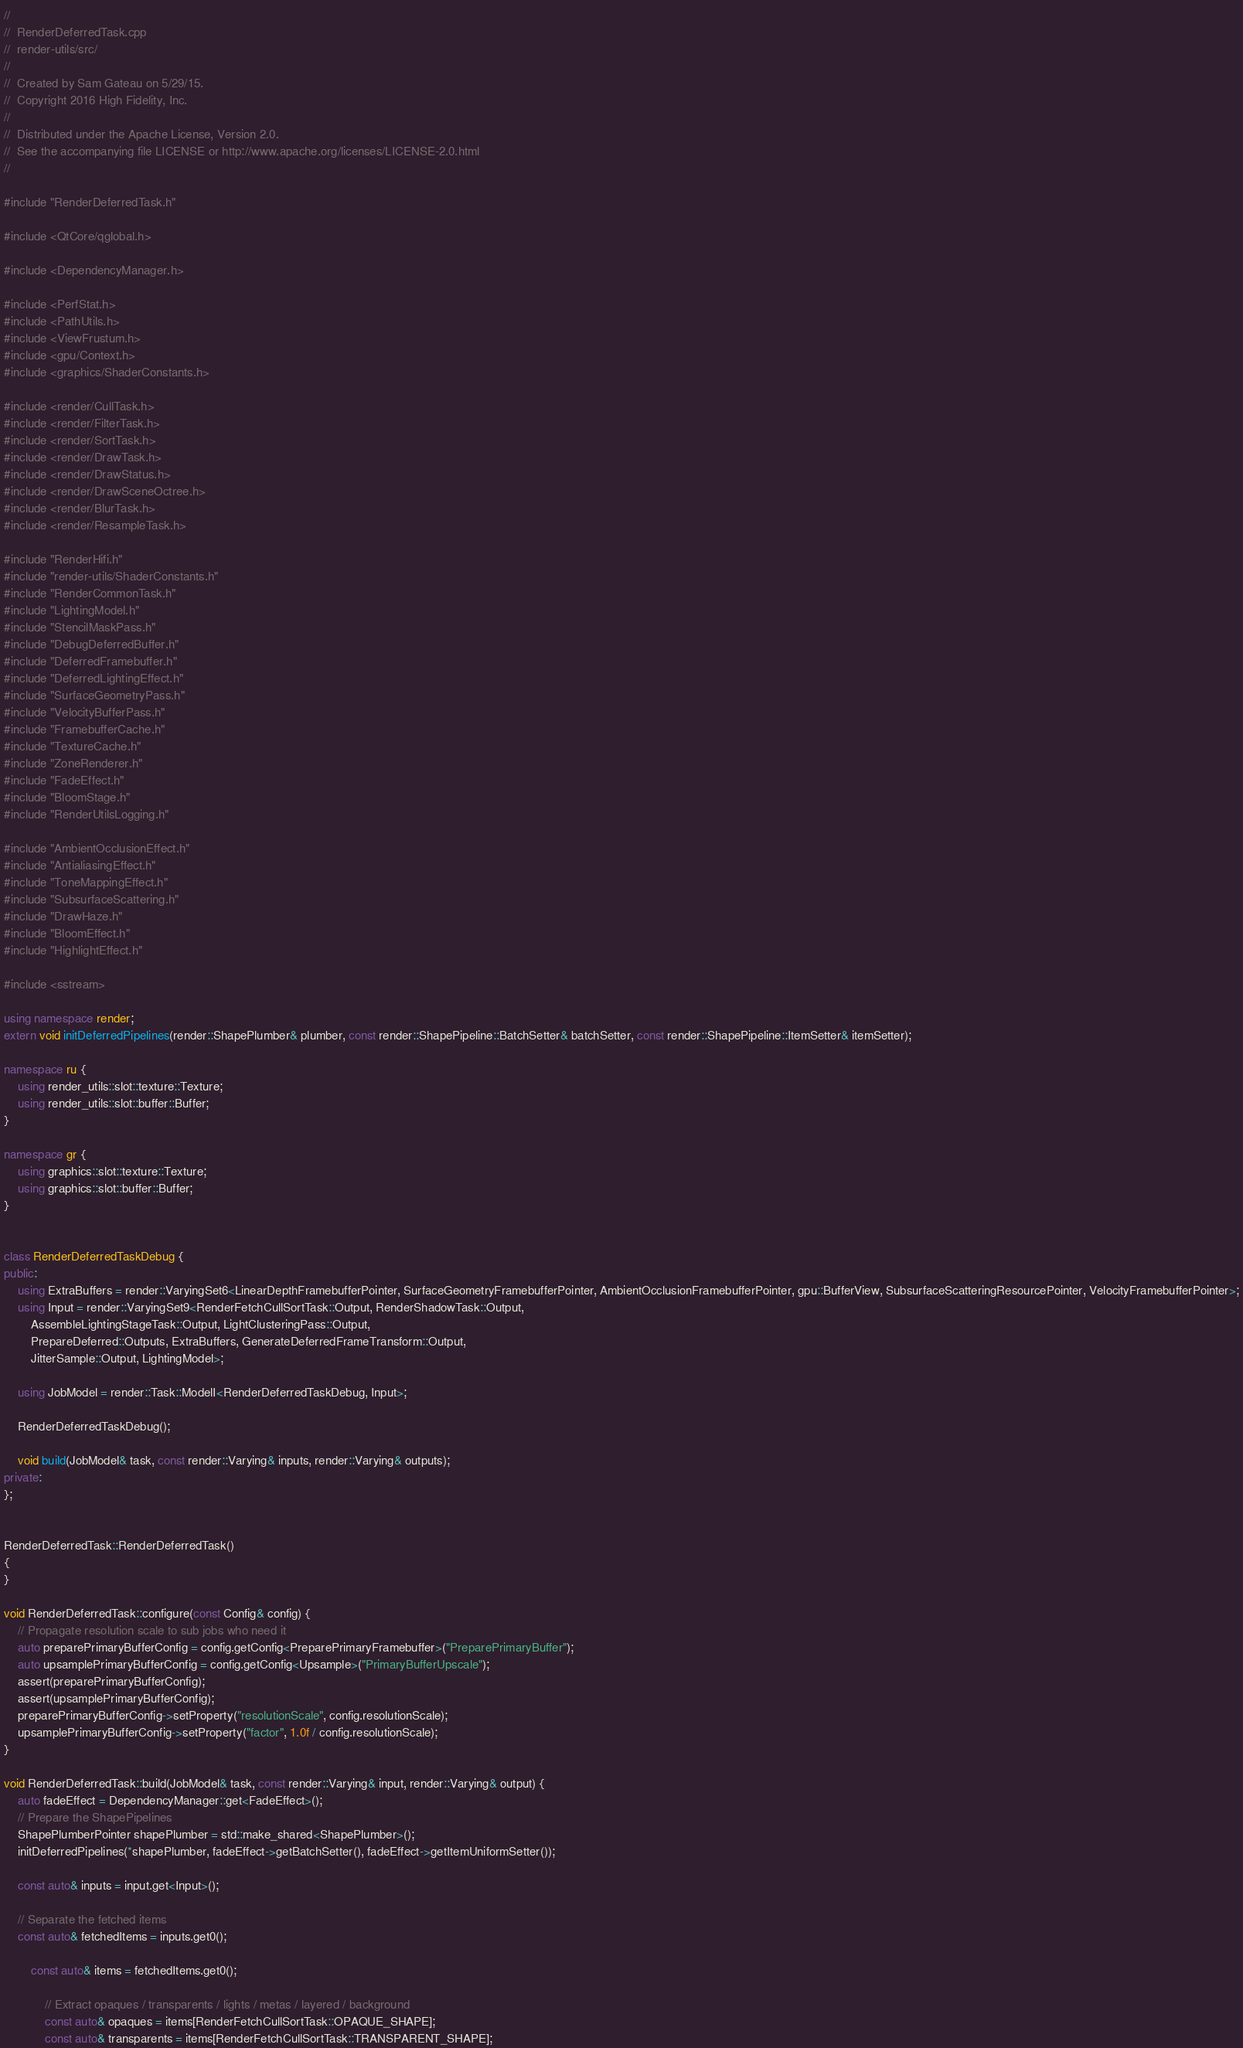<code> <loc_0><loc_0><loc_500><loc_500><_C++_>
//
//  RenderDeferredTask.cpp
//  render-utils/src/
//
//  Created by Sam Gateau on 5/29/15.
//  Copyright 2016 High Fidelity, Inc.
//
//  Distributed under the Apache License, Version 2.0.
//  See the accompanying file LICENSE or http://www.apache.org/licenses/LICENSE-2.0.html
//

#include "RenderDeferredTask.h"

#include <QtCore/qglobal.h>

#include <DependencyManager.h>

#include <PerfStat.h>
#include <PathUtils.h>
#include <ViewFrustum.h>
#include <gpu/Context.h>
#include <graphics/ShaderConstants.h>

#include <render/CullTask.h>
#include <render/FilterTask.h>
#include <render/SortTask.h>
#include <render/DrawTask.h>
#include <render/DrawStatus.h>
#include <render/DrawSceneOctree.h>
#include <render/BlurTask.h>
#include <render/ResampleTask.h>

#include "RenderHifi.h"
#include "render-utils/ShaderConstants.h"
#include "RenderCommonTask.h"
#include "LightingModel.h"
#include "StencilMaskPass.h"
#include "DebugDeferredBuffer.h"
#include "DeferredFramebuffer.h"
#include "DeferredLightingEffect.h"
#include "SurfaceGeometryPass.h"
#include "VelocityBufferPass.h"
#include "FramebufferCache.h"
#include "TextureCache.h"
#include "ZoneRenderer.h"
#include "FadeEffect.h"
#include "BloomStage.h"
#include "RenderUtilsLogging.h"

#include "AmbientOcclusionEffect.h"
#include "AntialiasingEffect.h"
#include "ToneMappingEffect.h"
#include "SubsurfaceScattering.h"
#include "DrawHaze.h"
#include "BloomEffect.h"
#include "HighlightEffect.h"

#include <sstream>

using namespace render;
extern void initDeferredPipelines(render::ShapePlumber& plumber, const render::ShapePipeline::BatchSetter& batchSetter, const render::ShapePipeline::ItemSetter& itemSetter);

namespace ru {
    using render_utils::slot::texture::Texture;
    using render_utils::slot::buffer::Buffer;
}

namespace gr {
    using graphics::slot::texture::Texture;
    using graphics::slot::buffer::Buffer;
}


class RenderDeferredTaskDebug {
public:
    using ExtraBuffers = render::VaryingSet6<LinearDepthFramebufferPointer, SurfaceGeometryFramebufferPointer, AmbientOcclusionFramebufferPointer, gpu::BufferView, SubsurfaceScatteringResourcePointer, VelocityFramebufferPointer>;
    using Input = render::VaryingSet9<RenderFetchCullSortTask::Output, RenderShadowTask::Output,
        AssembleLightingStageTask::Output, LightClusteringPass::Output, 
        PrepareDeferred::Outputs, ExtraBuffers, GenerateDeferredFrameTransform::Output,
        JitterSample::Output, LightingModel>;

    using JobModel = render::Task::ModelI<RenderDeferredTaskDebug, Input>;

    RenderDeferredTaskDebug();

    void build(JobModel& task, const render::Varying& inputs, render::Varying& outputs);
private:
};


RenderDeferredTask::RenderDeferredTask()
{
}

void RenderDeferredTask::configure(const Config& config) {
    // Propagate resolution scale to sub jobs who need it
    auto preparePrimaryBufferConfig = config.getConfig<PreparePrimaryFramebuffer>("PreparePrimaryBuffer");
    auto upsamplePrimaryBufferConfig = config.getConfig<Upsample>("PrimaryBufferUpscale");
    assert(preparePrimaryBufferConfig);
    assert(upsamplePrimaryBufferConfig);
    preparePrimaryBufferConfig->setProperty("resolutionScale", config.resolutionScale);
    upsamplePrimaryBufferConfig->setProperty("factor", 1.0f / config.resolutionScale);
}

void RenderDeferredTask::build(JobModel& task, const render::Varying& input, render::Varying& output) {
    auto fadeEffect = DependencyManager::get<FadeEffect>();
    // Prepare the ShapePipelines
    ShapePlumberPointer shapePlumber = std::make_shared<ShapePlumber>();
    initDeferredPipelines(*shapePlumber, fadeEffect->getBatchSetter(), fadeEffect->getItemUniformSetter());

    const auto& inputs = input.get<Input>();
    
    // Separate the fetched items
    const auto& fetchedItems = inputs.get0();

        const auto& items = fetchedItems.get0();

            // Extract opaques / transparents / lights / metas / layered / background
            const auto& opaques = items[RenderFetchCullSortTask::OPAQUE_SHAPE];
            const auto& transparents = items[RenderFetchCullSortTask::TRANSPARENT_SHAPE];</code> 